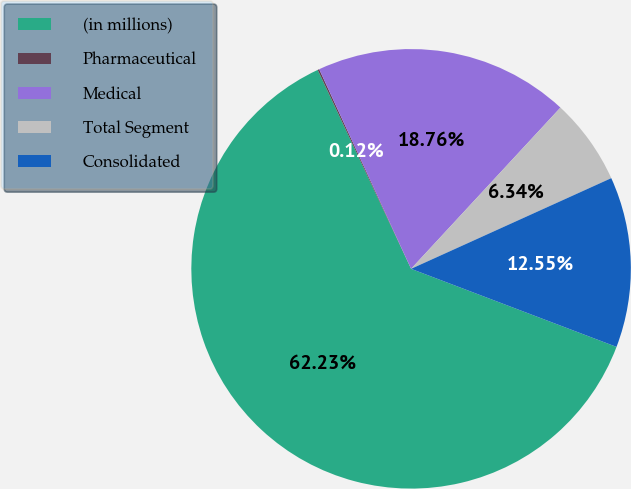<chart> <loc_0><loc_0><loc_500><loc_500><pie_chart><fcel>(in millions)<fcel>Pharmaceutical<fcel>Medical<fcel>Total Segment<fcel>Consolidated<nl><fcel>62.24%<fcel>0.12%<fcel>18.76%<fcel>6.34%<fcel>12.55%<nl></chart> 